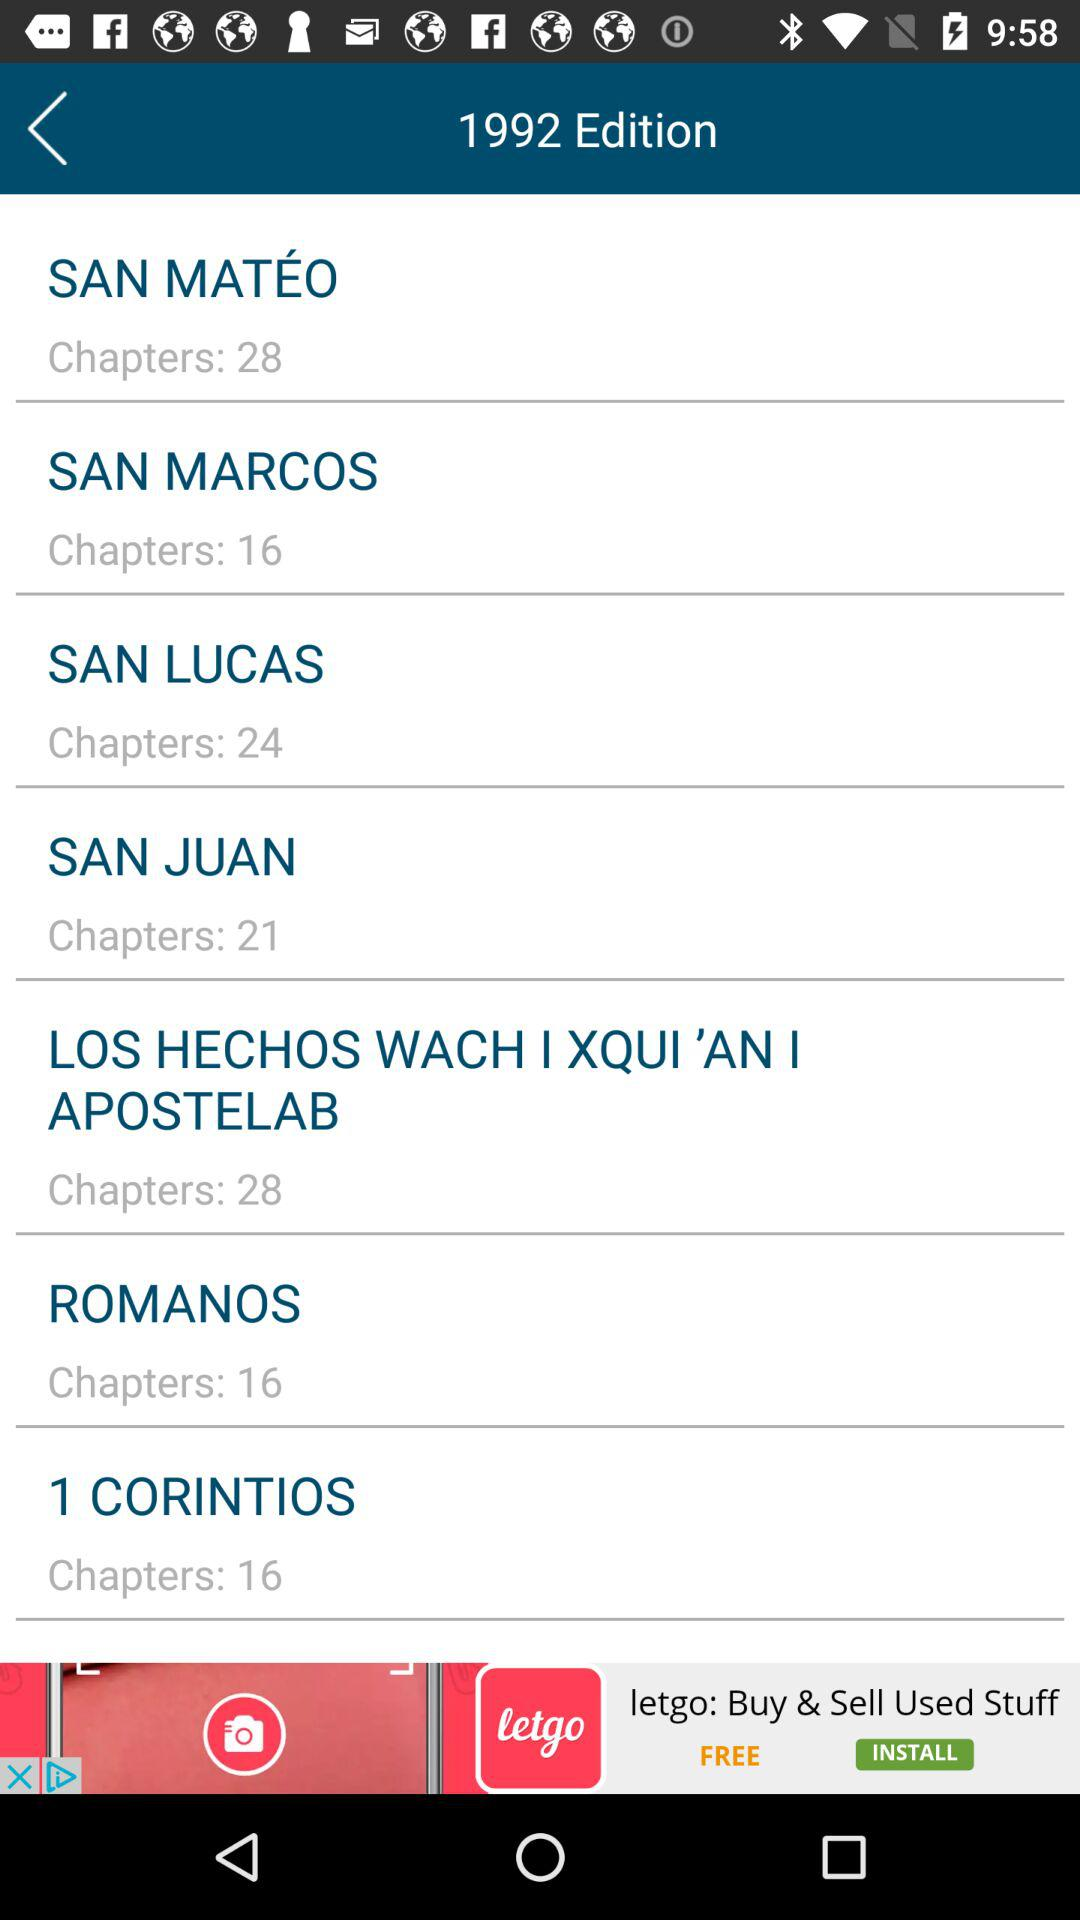Who published the 1992 edition?
When the provided information is insufficient, respond with <no answer>. <no answer> 